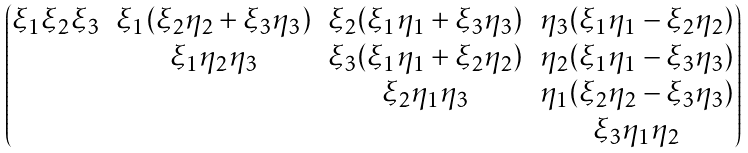Convert formula to latex. <formula><loc_0><loc_0><loc_500><loc_500>\begin{pmatrix} \xi _ { 1 } \xi _ { 2 } \xi _ { 3 } & \xi _ { 1 } ( \xi _ { 2 } \eta _ { 2 } + \xi _ { 3 } \eta _ { 3 } ) & \xi _ { 2 } ( \xi _ { 1 } \eta _ { 1 } + \xi _ { 3 } \eta _ { 3 } ) & \eta _ { 3 } ( \xi _ { 1 } \eta _ { 1 } - \xi _ { 2 } \eta _ { 2 } ) \\ & \xi _ { 1 } \eta _ { 2 } \eta _ { 3 } & \xi _ { 3 } ( \xi _ { 1 } \eta _ { 1 } + \xi _ { 2 } \eta _ { 2 } ) & \eta _ { 2 } ( \xi _ { 1 } \eta _ { 1 } - \xi _ { 3 } \eta _ { 3 } ) \\ & & \xi _ { 2 } \eta _ { 1 } \eta _ { 3 } & \eta _ { 1 } ( \xi _ { 2 } \eta _ { 2 } - \xi _ { 3 } \eta _ { 3 } ) \\ & & & \xi _ { 3 } \eta _ { 1 } \eta _ { 2 } \\ \end{pmatrix}</formula> 